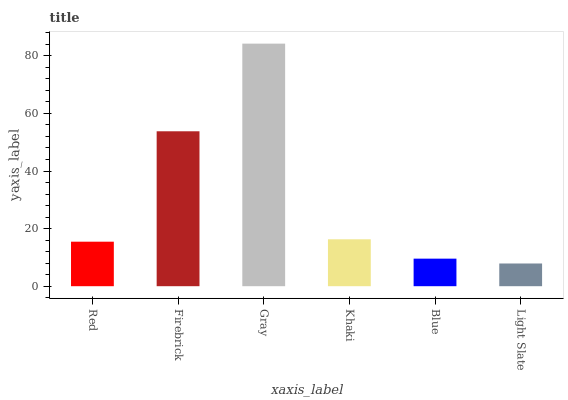Is Firebrick the minimum?
Answer yes or no. No. Is Firebrick the maximum?
Answer yes or no. No. Is Firebrick greater than Red?
Answer yes or no. Yes. Is Red less than Firebrick?
Answer yes or no. Yes. Is Red greater than Firebrick?
Answer yes or no. No. Is Firebrick less than Red?
Answer yes or no. No. Is Khaki the high median?
Answer yes or no. Yes. Is Red the low median?
Answer yes or no. Yes. Is Firebrick the high median?
Answer yes or no. No. Is Khaki the low median?
Answer yes or no. No. 